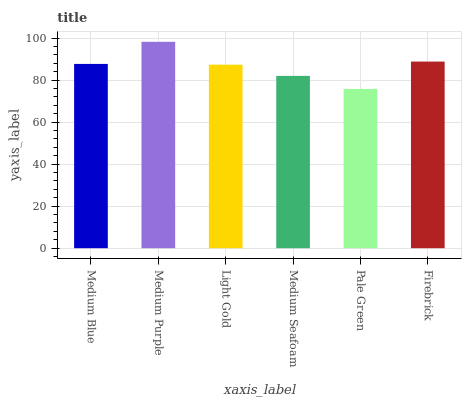Is Pale Green the minimum?
Answer yes or no. Yes. Is Medium Purple the maximum?
Answer yes or no. Yes. Is Light Gold the minimum?
Answer yes or no. No. Is Light Gold the maximum?
Answer yes or no. No. Is Medium Purple greater than Light Gold?
Answer yes or no. Yes. Is Light Gold less than Medium Purple?
Answer yes or no. Yes. Is Light Gold greater than Medium Purple?
Answer yes or no. No. Is Medium Purple less than Light Gold?
Answer yes or no. No. Is Medium Blue the high median?
Answer yes or no. Yes. Is Light Gold the low median?
Answer yes or no. Yes. Is Firebrick the high median?
Answer yes or no. No. Is Medium Blue the low median?
Answer yes or no. No. 